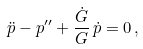Convert formula to latex. <formula><loc_0><loc_0><loc_500><loc_500>\ddot { p } - p ^ { \prime \prime } + \frac { \dot { G } } { G } \, \dot { p } = 0 \, ,</formula> 